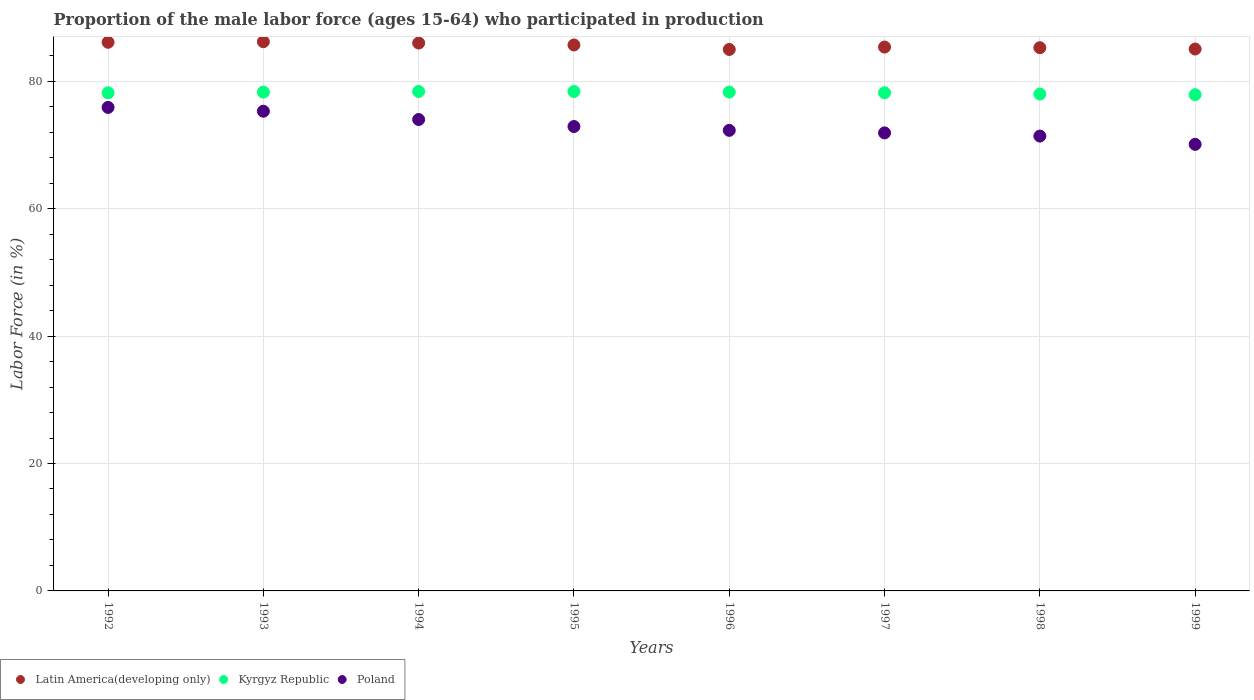Is the number of dotlines equal to the number of legend labels?
Your answer should be compact. Yes. What is the proportion of the male labor force who participated in production in Poland in 1993?
Make the answer very short. 75.3. Across all years, what is the maximum proportion of the male labor force who participated in production in Kyrgyz Republic?
Your answer should be very brief. 78.4. Across all years, what is the minimum proportion of the male labor force who participated in production in Poland?
Your response must be concise. 70.1. In which year was the proportion of the male labor force who participated in production in Kyrgyz Republic minimum?
Offer a terse response. 1999. What is the total proportion of the male labor force who participated in production in Kyrgyz Republic in the graph?
Offer a very short reply. 625.7. What is the difference between the proportion of the male labor force who participated in production in Latin America(developing only) in 1992 and that in 1997?
Provide a short and direct response. 0.75. What is the difference between the proportion of the male labor force who participated in production in Poland in 1998 and the proportion of the male labor force who participated in production in Latin America(developing only) in 1997?
Ensure brevity in your answer.  -13.97. What is the average proportion of the male labor force who participated in production in Latin America(developing only) per year?
Give a very brief answer. 85.6. In the year 1996, what is the difference between the proportion of the male labor force who participated in production in Latin America(developing only) and proportion of the male labor force who participated in production in Poland?
Your response must be concise. 12.7. In how many years, is the proportion of the male labor force who participated in production in Latin America(developing only) greater than 16 %?
Give a very brief answer. 8. What is the ratio of the proportion of the male labor force who participated in production in Kyrgyz Republic in 1996 to that in 1997?
Your answer should be very brief. 1. Is the proportion of the male labor force who participated in production in Kyrgyz Republic in 1993 less than that in 1997?
Your answer should be very brief. No. What is the difference between the highest and the second highest proportion of the male labor force who participated in production in Latin America(developing only)?
Give a very brief answer. 0.09. What is the difference between the highest and the lowest proportion of the male labor force who participated in production in Latin America(developing only)?
Offer a very short reply. 1.22. In how many years, is the proportion of the male labor force who participated in production in Kyrgyz Republic greater than the average proportion of the male labor force who participated in production in Kyrgyz Republic taken over all years?
Make the answer very short. 4. Is it the case that in every year, the sum of the proportion of the male labor force who participated in production in Latin America(developing only) and proportion of the male labor force who participated in production in Kyrgyz Republic  is greater than the proportion of the male labor force who participated in production in Poland?
Keep it short and to the point. Yes. Is the proportion of the male labor force who participated in production in Kyrgyz Republic strictly greater than the proportion of the male labor force who participated in production in Poland over the years?
Your response must be concise. Yes. Are the values on the major ticks of Y-axis written in scientific E-notation?
Your answer should be compact. No. Does the graph contain grids?
Offer a very short reply. Yes. What is the title of the graph?
Offer a very short reply. Proportion of the male labor force (ages 15-64) who participated in production. Does "Jordan" appear as one of the legend labels in the graph?
Offer a terse response. No. What is the label or title of the X-axis?
Offer a terse response. Years. What is the label or title of the Y-axis?
Give a very brief answer. Labor Force (in %). What is the Labor Force (in %) in Latin America(developing only) in 1992?
Ensure brevity in your answer.  86.12. What is the Labor Force (in %) of Kyrgyz Republic in 1992?
Provide a short and direct response. 78.2. What is the Labor Force (in %) in Poland in 1992?
Give a very brief answer. 75.9. What is the Labor Force (in %) in Latin America(developing only) in 1993?
Give a very brief answer. 86.21. What is the Labor Force (in %) in Kyrgyz Republic in 1993?
Make the answer very short. 78.3. What is the Labor Force (in %) in Poland in 1993?
Your answer should be very brief. 75.3. What is the Labor Force (in %) of Latin America(developing only) in 1994?
Give a very brief answer. 86.01. What is the Labor Force (in %) in Kyrgyz Republic in 1994?
Your answer should be very brief. 78.4. What is the Labor Force (in %) of Latin America(developing only) in 1995?
Provide a succinct answer. 85.7. What is the Labor Force (in %) in Kyrgyz Republic in 1995?
Your answer should be very brief. 78.4. What is the Labor Force (in %) of Poland in 1995?
Your answer should be very brief. 72.9. What is the Labor Force (in %) in Latin America(developing only) in 1996?
Your answer should be compact. 85. What is the Labor Force (in %) in Kyrgyz Republic in 1996?
Give a very brief answer. 78.3. What is the Labor Force (in %) in Poland in 1996?
Your response must be concise. 72.3. What is the Labor Force (in %) in Latin America(developing only) in 1997?
Your response must be concise. 85.37. What is the Labor Force (in %) in Kyrgyz Republic in 1997?
Ensure brevity in your answer.  78.2. What is the Labor Force (in %) of Poland in 1997?
Give a very brief answer. 71.9. What is the Labor Force (in %) in Latin America(developing only) in 1998?
Provide a succinct answer. 85.28. What is the Labor Force (in %) in Kyrgyz Republic in 1998?
Provide a succinct answer. 78. What is the Labor Force (in %) in Poland in 1998?
Provide a short and direct response. 71.4. What is the Labor Force (in %) in Latin America(developing only) in 1999?
Give a very brief answer. 85.06. What is the Labor Force (in %) in Kyrgyz Republic in 1999?
Offer a terse response. 77.9. What is the Labor Force (in %) in Poland in 1999?
Provide a short and direct response. 70.1. Across all years, what is the maximum Labor Force (in %) of Latin America(developing only)?
Provide a succinct answer. 86.21. Across all years, what is the maximum Labor Force (in %) in Kyrgyz Republic?
Offer a terse response. 78.4. Across all years, what is the maximum Labor Force (in %) of Poland?
Ensure brevity in your answer.  75.9. Across all years, what is the minimum Labor Force (in %) of Latin America(developing only)?
Make the answer very short. 85. Across all years, what is the minimum Labor Force (in %) of Kyrgyz Republic?
Keep it short and to the point. 77.9. Across all years, what is the minimum Labor Force (in %) of Poland?
Give a very brief answer. 70.1. What is the total Labor Force (in %) in Latin America(developing only) in the graph?
Your answer should be very brief. 684.76. What is the total Labor Force (in %) in Kyrgyz Republic in the graph?
Provide a short and direct response. 625.7. What is the total Labor Force (in %) in Poland in the graph?
Give a very brief answer. 583.8. What is the difference between the Labor Force (in %) in Latin America(developing only) in 1992 and that in 1993?
Ensure brevity in your answer.  -0.09. What is the difference between the Labor Force (in %) of Kyrgyz Republic in 1992 and that in 1993?
Your response must be concise. -0.1. What is the difference between the Labor Force (in %) in Poland in 1992 and that in 1993?
Keep it short and to the point. 0.6. What is the difference between the Labor Force (in %) in Latin America(developing only) in 1992 and that in 1994?
Give a very brief answer. 0.12. What is the difference between the Labor Force (in %) of Poland in 1992 and that in 1994?
Provide a succinct answer. 1.9. What is the difference between the Labor Force (in %) of Latin America(developing only) in 1992 and that in 1995?
Keep it short and to the point. 0.42. What is the difference between the Labor Force (in %) in Kyrgyz Republic in 1992 and that in 1995?
Your answer should be compact. -0.2. What is the difference between the Labor Force (in %) in Latin America(developing only) in 1992 and that in 1996?
Keep it short and to the point. 1.13. What is the difference between the Labor Force (in %) of Poland in 1992 and that in 1996?
Your answer should be compact. 3.6. What is the difference between the Labor Force (in %) in Latin America(developing only) in 1992 and that in 1997?
Your response must be concise. 0.75. What is the difference between the Labor Force (in %) in Poland in 1992 and that in 1997?
Make the answer very short. 4. What is the difference between the Labor Force (in %) in Latin America(developing only) in 1992 and that in 1998?
Give a very brief answer. 0.85. What is the difference between the Labor Force (in %) in Kyrgyz Republic in 1992 and that in 1998?
Your answer should be very brief. 0.2. What is the difference between the Labor Force (in %) of Poland in 1992 and that in 1998?
Make the answer very short. 4.5. What is the difference between the Labor Force (in %) of Latin America(developing only) in 1992 and that in 1999?
Your response must be concise. 1.06. What is the difference between the Labor Force (in %) of Latin America(developing only) in 1993 and that in 1994?
Make the answer very short. 0.21. What is the difference between the Labor Force (in %) in Latin America(developing only) in 1993 and that in 1995?
Make the answer very short. 0.51. What is the difference between the Labor Force (in %) of Kyrgyz Republic in 1993 and that in 1995?
Your answer should be compact. -0.1. What is the difference between the Labor Force (in %) of Poland in 1993 and that in 1995?
Offer a terse response. 2.4. What is the difference between the Labor Force (in %) of Latin America(developing only) in 1993 and that in 1996?
Offer a terse response. 1.22. What is the difference between the Labor Force (in %) in Kyrgyz Republic in 1993 and that in 1996?
Offer a terse response. 0. What is the difference between the Labor Force (in %) of Poland in 1993 and that in 1996?
Keep it short and to the point. 3. What is the difference between the Labor Force (in %) in Latin America(developing only) in 1993 and that in 1997?
Your answer should be very brief. 0.84. What is the difference between the Labor Force (in %) in Kyrgyz Republic in 1993 and that in 1997?
Keep it short and to the point. 0.1. What is the difference between the Labor Force (in %) in Latin America(developing only) in 1993 and that in 1998?
Offer a terse response. 0.94. What is the difference between the Labor Force (in %) of Kyrgyz Republic in 1993 and that in 1998?
Offer a very short reply. 0.3. What is the difference between the Labor Force (in %) in Latin America(developing only) in 1993 and that in 1999?
Offer a very short reply. 1.15. What is the difference between the Labor Force (in %) of Latin America(developing only) in 1994 and that in 1995?
Make the answer very short. 0.3. What is the difference between the Labor Force (in %) of Poland in 1994 and that in 1995?
Ensure brevity in your answer.  1.1. What is the difference between the Labor Force (in %) of Poland in 1994 and that in 1996?
Keep it short and to the point. 1.7. What is the difference between the Labor Force (in %) in Latin America(developing only) in 1994 and that in 1997?
Keep it short and to the point. 0.63. What is the difference between the Labor Force (in %) in Poland in 1994 and that in 1997?
Your response must be concise. 2.1. What is the difference between the Labor Force (in %) of Latin America(developing only) in 1994 and that in 1998?
Keep it short and to the point. 0.73. What is the difference between the Labor Force (in %) in Latin America(developing only) in 1994 and that in 1999?
Keep it short and to the point. 0.94. What is the difference between the Labor Force (in %) of Latin America(developing only) in 1995 and that in 1996?
Make the answer very short. 0.71. What is the difference between the Labor Force (in %) of Kyrgyz Republic in 1995 and that in 1996?
Provide a succinct answer. 0.1. What is the difference between the Labor Force (in %) in Latin America(developing only) in 1995 and that in 1997?
Keep it short and to the point. 0.33. What is the difference between the Labor Force (in %) in Poland in 1995 and that in 1997?
Your response must be concise. 1. What is the difference between the Labor Force (in %) of Latin America(developing only) in 1995 and that in 1998?
Offer a very short reply. 0.43. What is the difference between the Labor Force (in %) of Latin America(developing only) in 1995 and that in 1999?
Make the answer very short. 0.64. What is the difference between the Labor Force (in %) of Latin America(developing only) in 1996 and that in 1997?
Offer a very short reply. -0.38. What is the difference between the Labor Force (in %) in Kyrgyz Republic in 1996 and that in 1997?
Your answer should be compact. 0.1. What is the difference between the Labor Force (in %) of Latin America(developing only) in 1996 and that in 1998?
Ensure brevity in your answer.  -0.28. What is the difference between the Labor Force (in %) in Kyrgyz Republic in 1996 and that in 1998?
Your answer should be compact. 0.3. What is the difference between the Labor Force (in %) of Latin America(developing only) in 1996 and that in 1999?
Give a very brief answer. -0.07. What is the difference between the Labor Force (in %) in Kyrgyz Republic in 1996 and that in 1999?
Your response must be concise. 0.4. What is the difference between the Labor Force (in %) of Poland in 1996 and that in 1999?
Offer a terse response. 2.2. What is the difference between the Labor Force (in %) of Latin America(developing only) in 1997 and that in 1998?
Ensure brevity in your answer.  0.1. What is the difference between the Labor Force (in %) in Kyrgyz Republic in 1997 and that in 1998?
Offer a very short reply. 0.2. What is the difference between the Labor Force (in %) of Latin America(developing only) in 1997 and that in 1999?
Your answer should be very brief. 0.31. What is the difference between the Labor Force (in %) in Latin America(developing only) in 1998 and that in 1999?
Ensure brevity in your answer.  0.21. What is the difference between the Labor Force (in %) in Poland in 1998 and that in 1999?
Your response must be concise. 1.3. What is the difference between the Labor Force (in %) in Latin America(developing only) in 1992 and the Labor Force (in %) in Kyrgyz Republic in 1993?
Your response must be concise. 7.82. What is the difference between the Labor Force (in %) of Latin America(developing only) in 1992 and the Labor Force (in %) of Poland in 1993?
Your response must be concise. 10.82. What is the difference between the Labor Force (in %) in Latin America(developing only) in 1992 and the Labor Force (in %) in Kyrgyz Republic in 1994?
Keep it short and to the point. 7.72. What is the difference between the Labor Force (in %) in Latin America(developing only) in 1992 and the Labor Force (in %) in Poland in 1994?
Your answer should be compact. 12.12. What is the difference between the Labor Force (in %) of Kyrgyz Republic in 1992 and the Labor Force (in %) of Poland in 1994?
Offer a very short reply. 4.2. What is the difference between the Labor Force (in %) in Latin America(developing only) in 1992 and the Labor Force (in %) in Kyrgyz Republic in 1995?
Your response must be concise. 7.72. What is the difference between the Labor Force (in %) of Latin America(developing only) in 1992 and the Labor Force (in %) of Poland in 1995?
Offer a very short reply. 13.22. What is the difference between the Labor Force (in %) in Latin America(developing only) in 1992 and the Labor Force (in %) in Kyrgyz Republic in 1996?
Give a very brief answer. 7.82. What is the difference between the Labor Force (in %) in Latin America(developing only) in 1992 and the Labor Force (in %) in Poland in 1996?
Give a very brief answer. 13.82. What is the difference between the Labor Force (in %) in Latin America(developing only) in 1992 and the Labor Force (in %) in Kyrgyz Republic in 1997?
Keep it short and to the point. 7.92. What is the difference between the Labor Force (in %) in Latin America(developing only) in 1992 and the Labor Force (in %) in Poland in 1997?
Give a very brief answer. 14.22. What is the difference between the Labor Force (in %) of Latin America(developing only) in 1992 and the Labor Force (in %) of Kyrgyz Republic in 1998?
Give a very brief answer. 8.12. What is the difference between the Labor Force (in %) of Latin America(developing only) in 1992 and the Labor Force (in %) of Poland in 1998?
Ensure brevity in your answer.  14.72. What is the difference between the Labor Force (in %) in Kyrgyz Republic in 1992 and the Labor Force (in %) in Poland in 1998?
Your answer should be compact. 6.8. What is the difference between the Labor Force (in %) in Latin America(developing only) in 1992 and the Labor Force (in %) in Kyrgyz Republic in 1999?
Offer a very short reply. 8.22. What is the difference between the Labor Force (in %) of Latin America(developing only) in 1992 and the Labor Force (in %) of Poland in 1999?
Offer a very short reply. 16.02. What is the difference between the Labor Force (in %) in Kyrgyz Republic in 1992 and the Labor Force (in %) in Poland in 1999?
Make the answer very short. 8.1. What is the difference between the Labor Force (in %) of Latin America(developing only) in 1993 and the Labor Force (in %) of Kyrgyz Republic in 1994?
Your response must be concise. 7.81. What is the difference between the Labor Force (in %) in Latin America(developing only) in 1993 and the Labor Force (in %) in Poland in 1994?
Your response must be concise. 12.21. What is the difference between the Labor Force (in %) of Kyrgyz Republic in 1993 and the Labor Force (in %) of Poland in 1994?
Your answer should be compact. 4.3. What is the difference between the Labor Force (in %) of Latin America(developing only) in 1993 and the Labor Force (in %) of Kyrgyz Republic in 1995?
Give a very brief answer. 7.81. What is the difference between the Labor Force (in %) in Latin America(developing only) in 1993 and the Labor Force (in %) in Poland in 1995?
Make the answer very short. 13.31. What is the difference between the Labor Force (in %) of Kyrgyz Republic in 1993 and the Labor Force (in %) of Poland in 1995?
Provide a succinct answer. 5.4. What is the difference between the Labor Force (in %) in Latin America(developing only) in 1993 and the Labor Force (in %) in Kyrgyz Republic in 1996?
Provide a short and direct response. 7.91. What is the difference between the Labor Force (in %) in Latin America(developing only) in 1993 and the Labor Force (in %) in Poland in 1996?
Offer a terse response. 13.91. What is the difference between the Labor Force (in %) in Kyrgyz Republic in 1993 and the Labor Force (in %) in Poland in 1996?
Your answer should be very brief. 6. What is the difference between the Labor Force (in %) of Latin America(developing only) in 1993 and the Labor Force (in %) of Kyrgyz Republic in 1997?
Your answer should be very brief. 8.01. What is the difference between the Labor Force (in %) of Latin America(developing only) in 1993 and the Labor Force (in %) of Poland in 1997?
Make the answer very short. 14.31. What is the difference between the Labor Force (in %) of Kyrgyz Republic in 1993 and the Labor Force (in %) of Poland in 1997?
Provide a succinct answer. 6.4. What is the difference between the Labor Force (in %) of Latin America(developing only) in 1993 and the Labor Force (in %) of Kyrgyz Republic in 1998?
Provide a short and direct response. 8.21. What is the difference between the Labor Force (in %) of Latin America(developing only) in 1993 and the Labor Force (in %) of Poland in 1998?
Ensure brevity in your answer.  14.81. What is the difference between the Labor Force (in %) of Kyrgyz Republic in 1993 and the Labor Force (in %) of Poland in 1998?
Offer a very short reply. 6.9. What is the difference between the Labor Force (in %) in Latin America(developing only) in 1993 and the Labor Force (in %) in Kyrgyz Republic in 1999?
Your response must be concise. 8.31. What is the difference between the Labor Force (in %) in Latin America(developing only) in 1993 and the Labor Force (in %) in Poland in 1999?
Keep it short and to the point. 16.11. What is the difference between the Labor Force (in %) in Latin America(developing only) in 1994 and the Labor Force (in %) in Kyrgyz Republic in 1995?
Your answer should be compact. 7.61. What is the difference between the Labor Force (in %) of Latin America(developing only) in 1994 and the Labor Force (in %) of Poland in 1995?
Offer a terse response. 13.11. What is the difference between the Labor Force (in %) of Kyrgyz Republic in 1994 and the Labor Force (in %) of Poland in 1995?
Give a very brief answer. 5.5. What is the difference between the Labor Force (in %) of Latin America(developing only) in 1994 and the Labor Force (in %) of Kyrgyz Republic in 1996?
Your answer should be compact. 7.71. What is the difference between the Labor Force (in %) of Latin America(developing only) in 1994 and the Labor Force (in %) of Poland in 1996?
Your answer should be compact. 13.71. What is the difference between the Labor Force (in %) in Kyrgyz Republic in 1994 and the Labor Force (in %) in Poland in 1996?
Your answer should be compact. 6.1. What is the difference between the Labor Force (in %) of Latin America(developing only) in 1994 and the Labor Force (in %) of Kyrgyz Republic in 1997?
Provide a short and direct response. 7.81. What is the difference between the Labor Force (in %) of Latin America(developing only) in 1994 and the Labor Force (in %) of Poland in 1997?
Offer a terse response. 14.11. What is the difference between the Labor Force (in %) in Latin America(developing only) in 1994 and the Labor Force (in %) in Kyrgyz Republic in 1998?
Your response must be concise. 8.01. What is the difference between the Labor Force (in %) of Latin America(developing only) in 1994 and the Labor Force (in %) of Poland in 1998?
Your answer should be compact. 14.61. What is the difference between the Labor Force (in %) of Kyrgyz Republic in 1994 and the Labor Force (in %) of Poland in 1998?
Your response must be concise. 7. What is the difference between the Labor Force (in %) of Latin America(developing only) in 1994 and the Labor Force (in %) of Kyrgyz Republic in 1999?
Offer a very short reply. 8.11. What is the difference between the Labor Force (in %) in Latin America(developing only) in 1994 and the Labor Force (in %) in Poland in 1999?
Give a very brief answer. 15.91. What is the difference between the Labor Force (in %) in Kyrgyz Republic in 1994 and the Labor Force (in %) in Poland in 1999?
Ensure brevity in your answer.  8.3. What is the difference between the Labor Force (in %) of Latin America(developing only) in 1995 and the Labor Force (in %) of Kyrgyz Republic in 1996?
Give a very brief answer. 7.4. What is the difference between the Labor Force (in %) in Latin America(developing only) in 1995 and the Labor Force (in %) in Poland in 1996?
Give a very brief answer. 13.4. What is the difference between the Labor Force (in %) in Latin America(developing only) in 1995 and the Labor Force (in %) in Kyrgyz Republic in 1997?
Your response must be concise. 7.5. What is the difference between the Labor Force (in %) of Latin America(developing only) in 1995 and the Labor Force (in %) of Poland in 1997?
Your answer should be very brief. 13.8. What is the difference between the Labor Force (in %) of Kyrgyz Republic in 1995 and the Labor Force (in %) of Poland in 1997?
Offer a very short reply. 6.5. What is the difference between the Labor Force (in %) of Latin America(developing only) in 1995 and the Labor Force (in %) of Kyrgyz Republic in 1998?
Give a very brief answer. 7.7. What is the difference between the Labor Force (in %) of Latin America(developing only) in 1995 and the Labor Force (in %) of Poland in 1998?
Your answer should be very brief. 14.3. What is the difference between the Labor Force (in %) of Kyrgyz Republic in 1995 and the Labor Force (in %) of Poland in 1998?
Offer a terse response. 7. What is the difference between the Labor Force (in %) of Latin America(developing only) in 1995 and the Labor Force (in %) of Kyrgyz Republic in 1999?
Your answer should be compact. 7.8. What is the difference between the Labor Force (in %) in Latin America(developing only) in 1995 and the Labor Force (in %) in Poland in 1999?
Your answer should be compact. 15.6. What is the difference between the Labor Force (in %) in Latin America(developing only) in 1996 and the Labor Force (in %) in Kyrgyz Republic in 1997?
Offer a very short reply. 6.8. What is the difference between the Labor Force (in %) in Latin America(developing only) in 1996 and the Labor Force (in %) in Poland in 1997?
Your answer should be very brief. 13.1. What is the difference between the Labor Force (in %) in Latin America(developing only) in 1996 and the Labor Force (in %) in Kyrgyz Republic in 1998?
Make the answer very short. 7. What is the difference between the Labor Force (in %) in Latin America(developing only) in 1996 and the Labor Force (in %) in Poland in 1998?
Ensure brevity in your answer.  13.6. What is the difference between the Labor Force (in %) of Kyrgyz Republic in 1996 and the Labor Force (in %) of Poland in 1998?
Offer a very short reply. 6.9. What is the difference between the Labor Force (in %) in Latin America(developing only) in 1996 and the Labor Force (in %) in Kyrgyz Republic in 1999?
Your answer should be compact. 7.1. What is the difference between the Labor Force (in %) in Latin America(developing only) in 1996 and the Labor Force (in %) in Poland in 1999?
Your answer should be compact. 14.9. What is the difference between the Labor Force (in %) of Kyrgyz Republic in 1996 and the Labor Force (in %) of Poland in 1999?
Provide a succinct answer. 8.2. What is the difference between the Labor Force (in %) in Latin America(developing only) in 1997 and the Labor Force (in %) in Kyrgyz Republic in 1998?
Ensure brevity in your answer.  7.37. What is the difference between the Labor Force (in %) in Latin America(developing only) in 1997 and the Labor Force (in %) in Poland in 1998?
Offer a very short reply. 13.97. What is the difference between the Labor Force (in %) of Kyrgyz Republic in 1997 and the Labor Force (in %) of Poland in 1998?
Your answer should be compact. 6.8. What is the difference between the Labor Force (in %) in Latin America(developing only) in 1997 and the Labor Force (in %) in Kyrgyz Republic in 1999?
Provide a short and direct response. 7.47. What is the difference between the Labor Force (in %) of Latin America(developing only) in 1997 and the Labor Force (in %) of Poland in 1999?
Offer a very short reply. 15.27. What is the difference between the Labor Force (in %) of Kyrgyz Republic in 1997 and the Labor Force (in %) of Poland in 1999?
Ensure brevity in your answer.  8.1. What is the difference between the Labor Force (in %) of Latin America(developing only) in 1998 and the Labor Force (in %) of Kyrgyz Republic in 1999?
Give a very brief answer. 7.38. What is the difference between the Labor Force (in %) of Latin America(developing only) in 1998 and the Labor Force (in %) of Poland in 1999?
Your answer should be very brief. 15.18. What is the difference between the Labor Force (in %) of Kyrgyz Republic in 1998 and the Labor Force (in %) of Poland in 1999?
Keep it short and to the point. 7.9. What is the average Labor Force (in %) in Latin America(developing only) per year?
Your answer should be compact. 85.6. What is the average Labor Force (in %) of Kyrgyz Republic per year?
Your answer should be compact. 78.21. What is the average Labor Force (in %) of Poland per year?
Provide a succinct answer. 72.97. In the year 1992, what is the difference between the Labor Force (in %) of Latin America(developing only) and Labor Force (in %) of Kyrgyz Republic?
Your answer should be compact. 7.92. In the year 1992, what is the difference between the Labor Force (in %) of Latin America(developing only) and Labor Force (in %) of Poland?
Make the answer very short. 10.22. In the year 1993, what is the difference between the Labor Force (in %) in Latin America(developing only) and Labor Force (in %) in Kyrgyz Republic?
Provide a short and direct response. 7.91. In the year 1993, what is the difference between the Labor Force (in %) in Latin America(developing only) and Labor Force (in %) in Poland?
Provide a short and direct response. 10.91. In the year 1994, what is the difference between the Labor Force (in %) in Latin America(developing only) and Labor Force (in %) in Kyrgyz Republic?
Your response must be concise. 7.61. In the year 1994, what is the difference between the Labor Force (in %) in Latin America(developing only) and Labor Force (in %) in Poland?
Offer a very short reply. 12.01. In the year 1995, what is the difference between the Labor Force (in %) in Latin America(developing only) and Labor Force (in %) in Kyrgyz Republic?
Offer a very short reply. 7.3. In the year 1995, what is the difference between the Labor Force (in %) in Latin America(developing only) and Labor Force (in %) in Poland?
Offer a very short reply. 12.8. In the year 1996, what is the difference between the Labor Force (in %) of Latin America(developing only) and Labor Force (in %) of Kyrgyz Republic?
Make the answer very short. 6.7. In the year 1996, what is the difference between the Labor Force (in %) of Latin America(developing only) and Labor Force (in %) of Poland?
Provide a short and direct response. 12.7. In the year 1996, what is the difference between the Labor Force (in %) of Kyrgyz Republic and Labor Force (in %) of Poland?
Provide a succinct answer. 6. In the year 1997, what is the difference between the Labor Force (in %) in Latin America(developing only) and Labor Force (in %) in Kyrgyz Republic?
Your response must be concise. 7.17. In the year 1997, what is the difference between the Labor Force (in %) in Latin America(developing only) and Labor Force (in %) in Poland?
Your response must be concise. 13.47. In the year 1998, what is the difference between the Labor Force (in %) in Latin America(developing only) and Labor Force (in %) in Kyrgyz Republic?
Your answer should be compact. 7.28. In the year 1998, what is the difference between the Labor Force (in %) in Latin America(developing only) and Labor Force (in %) in Poland?
Give a very brief answer. 13.88. In the year 1998, what is the difference between the Labor Force (in %) of Kyrgyz Republic and Labor Force (in %) of Poland?
Provide a short and direct response. 6.6. In the year 1999, what is the difference between the Labor Force (in %) of Latin America(developing only) and Labor Force (in %) of Kyrgyz Republic?
Ensure brevity in your answer.  7.16. In the year 1999, what is the difference between the Labor Force (in %) of Latin America(developing only) and Labor Force (in %) of Poland?
Give a very brief answer. 14.96. In the year 1999, what is the difference between the Labor Force (in %) in Kyrgyz Republic and Labor Force (in %) in Poland?
Provide a short and direct response. 7.8. What is the ratio of the Labor Force (in %) in Latin America(developing only) in 1992 to that in 1993?
Make the answer very short. 1. What is the ratio of the Labor Force (in %) of Kyrgyz Republic in 1992 to that in 1994?
Ensure brevity in your answer.  1. What is the ratio of the Labor Force (in %) in Poland in 1992 to that in 1994?
Provide a short and direct response. 1.03. What is the ratio of the Labor Force (in %) of Latin America(developing only) in 1992 to that in 1995?
Give a very brief answer. 1. What is the ratio of the Labor Force (in %) of Kyrgyz Republic in 1992 to that in 1995?
Keep it short and to the point. 1. What is the ratio of the Labor Force (in %) of Poland in 1992 to that in 1995?
Make the answer very short. 1.04. What is the ratio of the Labor Force (in %) in Latin America(developing only) in 1992 to that in 1996?
Your response must be concise. 1.01. What is the ratio of the Labor Force (in %) of Poland in 1992 to that in 1996?
Offer a very short reply. 1.05. What is the ratio of the Labor Force (in %) of Latin America(developing only) in 1992 to that in 1997?
Give a very brief answer. 1.01. What is the ratio of the Labor Force (in %) in Poland in 1992 to that in 1997?
Offer a terse response. 1.06. What is the ratio of the Labor Force (in %) in Latin America(developing only) in 1992 to that in 1998?
Provide a short and direct response. 1.01. What is the ratio of the Labor Force (in %) of Kyrgyz Republic in 1992 to that in 1998?
Keep it short and to the point. 1. What is the ratio of the Labor Force (in %) of Poland in 1992 to that in 1998?
Keep it short and to the point. 1.06. What is the ratio of the Labor Force (in %) of Latin America(developing only) in 1992 to that in 1999?
Your response must be concise. 1.01. What is the ratio of the Labor Force (in %) in Kyrgyz Republic in 1992 to that in 1999?
Offer a very short reply. 1. What is the ratio of the Labor Force (in %) of Poland in 1992 to that in 1999?
Make the answer very short. 1.08. What is the ratio of the Labor Force (in %) in Kyrgyz Republic in 1993 to that in 1994?
Ensure brevity in your answer.  1. What is the ratio of the Labor Force (in %) in Poland in 1993 to that in 1994?
Keep it short and to the point. 1.02. What is the ratio of the Labor Force (in %) of Latin America(developing only) in 1993 to that in 1995?
Keep it short and to the point. 1.01. What is the ratio of the Labor Force (in %) in Kyrgyz Republic in 1993 to that in 1995?
Ensure brevity in your answer.  1. What is the ratio of the Labor Force (in %) in Poland in 1993 to that in 1995?
Give a very brief answer. 1.03. What is the ratio of the Labor Force (in %) of Latin America(developing only) in 1993 to that in 1996?
Offer a very short reply. 1.01. What is the ratio of the Labor Force (in %) in Poland in 1993 to that in 1996?
Provide a succinct answer. 1.04. What is the ratio of the Labor Force (in %) in Latin America(developing only) in 1993 to that in 1997?
Offer a terse response. 1.01. What is the ratio of the Labor Force (in %) in Kyrgyz Republic in 1993 to that in 1997?
Give a very brief answer. 1. What is the ratio of the Labor Force (in %) in Poland in 1993 to that in 1997?
Offer a very short reply. 1.05. What is the ratio of the Labor Force (in %) in Latin America(developing only) in 1993 to that in 1998?
Offer a very short reply. 1.01. What is the ratio of the Labor Force (in %) of Poland in 1993 to that in 1998?
Keep it short and to the point. 1.05. What is the ratio of the Labor Force (in %) in Latin America(developing only) in 1993 to that in 1999?
Offer a terse response. 1.01. What is the ratio of the Labor Force (in %) in Kyrgyz Republic in 1993 to that in 1999?
Make the answer very short. 1.01. What is the ratio of the Labor Force (in %) in Poland in 1993 to that in 1999?
Your answer should be very brief. 1.07. What is the ratio of the Labor Force (in %) of Latin America(developing only) in 1994 to that in 1995?
Provide a short and direct response. 1. What is the ratio of the Labor Force (in %) of Kyrgyz Republic in 1994 to that in 1995?
Your answer should be compact. 1. What is the ratio of the Labor Force (in %) in Poland in 1994 to that in 1995?
Give a very brief answer. 1.02. What is the ratio of the Labor Force (in %) of Latin America(developing only) in 1994 to that in 1996?
Your answer should be compact. 1.01. What is the ratio of the Labor Force (in %) of Kyrgyz Republic in 1994 to that in 1996?
Provide a succinct answer. 1. What is the ratio of the Labor Force (in %) in Poland in 1994 to that in 1996?
Keep it short and to the point. 1.02. What is the ratio of the Labor Force (in %) of Latin America(developing only) in 1994 to that in 1997?
Ensure brevity in your answer.  1.01. What is the ratio of the Labor Force (in %) in Kyrgyz Republic in 1994 to that in 1997?
Provide a succinct answer. 1. What is the ratio of the Labor Force (in %) in Poland in 1994 to that in 1997?
Your response must be concise. 1.03. What is the ratio of the Labor Force (in %) of Latin America(developing only) in 1994 to that in 1998?
Your answer should be compact. 1.01. What is the ratio of the Labor Force (in %) in Poland in 1994 to that in 1998?
Provide a short and direct response. 1.04. What is the ratio of the Labor Force (in %) in Latin America(developing only) in 1994 to that in 1999?
Your response must be concise. 1.01. What is the ratio of the Labor Force (in %) of Kyrgyz Republic in 1994 to that in 1999?
Make the answer very short. 1.01. What is the ratio of the Labor Force (in %) in Poland in 1994 to that in 1999?
Ensure brevity in your answer.  1.06. What is the ratio of the Labor Force (in %) in Latin America(developing only) in 1995 to that in 1996?
Give a very brief answer. 1.01. What is the ratio of the Labor Force (in %) of Poland in 1995 to that in 1996?
Keep it short and to the point. 1.01. What is the ratio of the Labor Force (in %) of Latin America(developing only) in 1995 to that in 1997?
Give a very brief answer. 1. What is the ratio of the Labor Force (in %) of Kyrgyz Republic in 1995 to that in 1997?
Offer a very short reply. 1. What is the ratio of the Labor Force (in %) in Poland in 1995 to that in 1997?
Your answer should be very brief. 1.01. What is the ratio of the Labor Force (in %) of Kyrgyz Republic in 1995 to that in 1998?
Keep it short and to the point. 1.01. What is the ratio of the Labor Force (in %) in Latin America(developing only) in 1995 to that in 1999?
Ensure brevity in your answer.  1.01. What is the ratio of the Labor Force (in %) in Kyrgyz Republic in 1995 to that in 1999?
Offer a terse response. 1.01. What is the ratio of the Labor Force (in %) in Poland in 1995 to that in 1999?
Ensure brevity in your answer.  1.04. What is the ratio of the Labor Force (in %) of Latin America(developing only) in 1996 to that in 1997?
Make the answer very short. 1. What is the ratio of the Labor Force (in %) in Kyrgyz Republic in 1996 to that in 1997?
Your response must be concise. 1. What is the ratio of the Labor Force (in %) of Poland in 1996 to that in 1997?
Provide a short and direct response. 1.01. What is the ratio of the Labor Force (in %) of Kyrgyz Republic in 1996 to that in 1998?
Offer a very short reply. 1. What is the ratio of the Labor Force (in %) of Poland in 1996 to that in 1998?
Offer a very short reply. 1.01. What is the ratio of the Labor Force (in %) of Kyrgyz Republic in 1996 to that in 1999?
Offer a very short reply. 1.01. What is the ratio of the Labor Force (in %) of Poland in 1996 to that in 1999?
Provide a succinct answer. 1.03. What is the ratio of the Labor Force (in %) in Latin America(developing only) in 1997 to that in 1998?
Your answer should be very brief. 1. What is the ratio of the Labor Force (in %) in Kyrgyz Republic in 1997 to that in 1998?
Keep it short and to the point. 1. What is the ratio of the Labor Force (in %) of Latin America(developing only) in 1997 to that in 1999?
Provide a succinct answer. 1. What is the ratio of the Labor Force (in %) of Poland in 1997 to that in 1999?
Provide a succinct answer. 1.03. What is the ratio of the Labor Force (in %) of Latin America(developing only) in 1998 to that in 1999?
Offer a very short reply. 1. What is the ratio of the Labor Force (in %) of Poland in 1998 to that in 1999?
Offer a very short reply. 1.02. What is the difference between the highest and the second highest Labor Force (in %) of Latin America(developing only)?
Offer a very short reply. 0.09. What is the difference between the highest and the lowest Labor Force (in %) in Latin America(developing only)?
Your response must be concise. 1.22. What is the difference between the highest and the lowest Labor Force (in %) of Poland?
Provide a succinct answer. 5.8. 